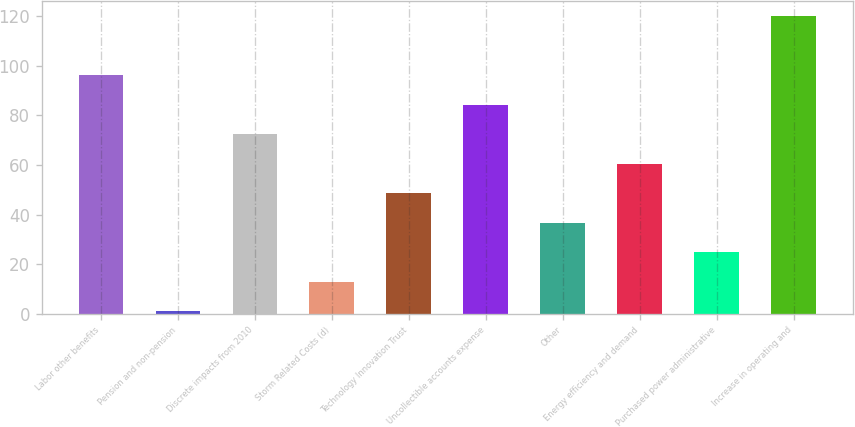Convert chart to OTSL. <chart><loc_0><loc_0><loc_500><loc_500><bar_chart><fcel>Labor other benefits<fcel>Pension and non-pension<fcel>Discrete impacts from 2010<fcel>Storm Related Costs (d)<fcel>Technology Innovation Trust<fcel>Uncollectible accounts expense<fcel>Other<fcel>Energy efficiency and demand<fcel>Purchased power administrative<fcel>Increase in operating and<nl><fcel>96.2<fcel>1<fcel>72.4<fcel>12.9<fcel>48.6<fcel>84.3<fcel>36.7<fcel>60.5<fcel>24.8<fcel>120<nl></chart> 